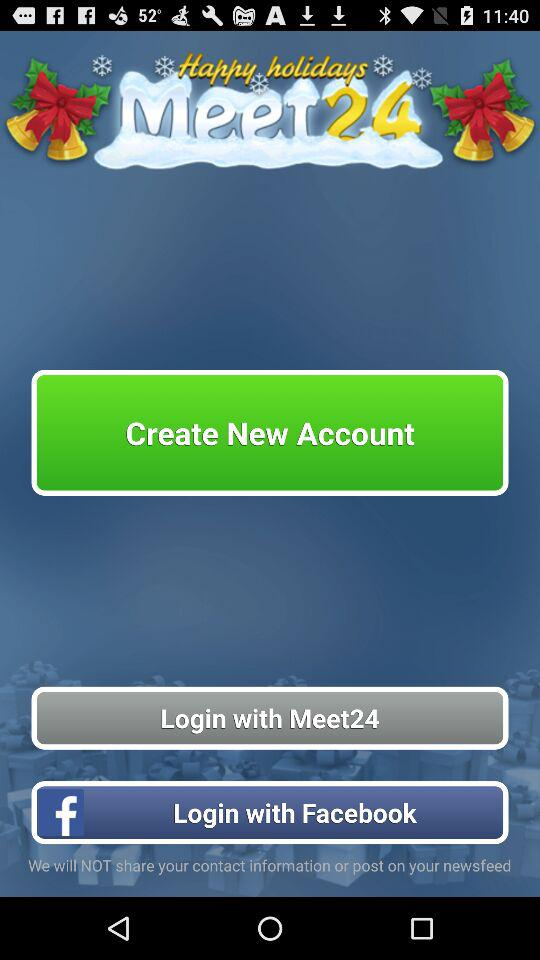What are the different options available for logging in? The different options available for logging in are "Meet24" and "Facebook". 